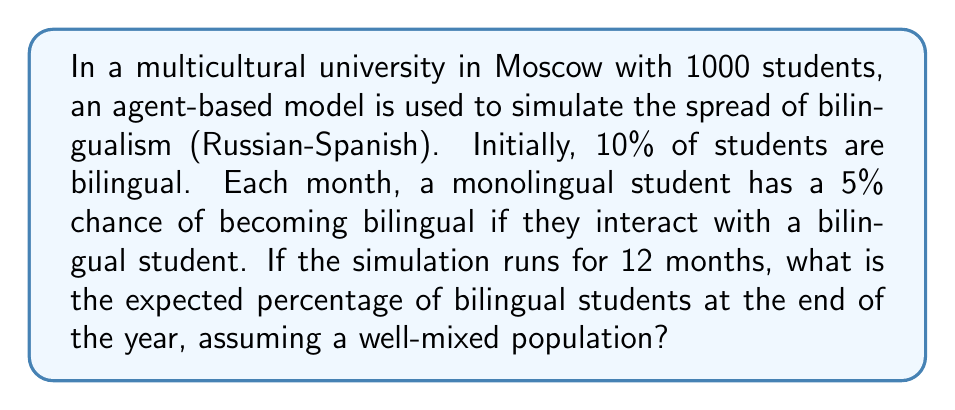Solve this math problem. Let's approach this step-by-step:

1) Initial conditions:
   - Total students: $N = 1000$
   - Initial bilingual students: $B_0 = 10\% \times 1000 = 100$
   - Initial monolingual students: $M_0 = 900$

2) For each month:
   - Probability of a monolingual student becoming bilingual: $p = 0.05$
   - Probability of remaining monolingual: $q = 1 - p = 0.95$

3) We can model this as a recursive process. For each month $t$:
   $B_t = B_{t-1} + (M_{t-1} \times p \times \frac{B_{t-1}}{N})$

   Where $\frac{B_{t-1}}{N}$ represents the probability of interacting with a bilingual student.

4) Let's calculate for 12 months:

   Month 1: $B_1 = 100 + (900 \times 0.05 \times \frac{100}{1000}) = 104.5$
   Month 2: $B_2 = 104.5 + (895.5 \times 0.05 \times \frac{104.5}{1000}) = 109.2$
   ...
   Month 12: $B_{12} \approx 161.8$

5) The percentage of bilingual students after 12 months:
   $\frac{161.8}{1000} \times 100\% \approx 16.18\%$
Answer: 16.18% 